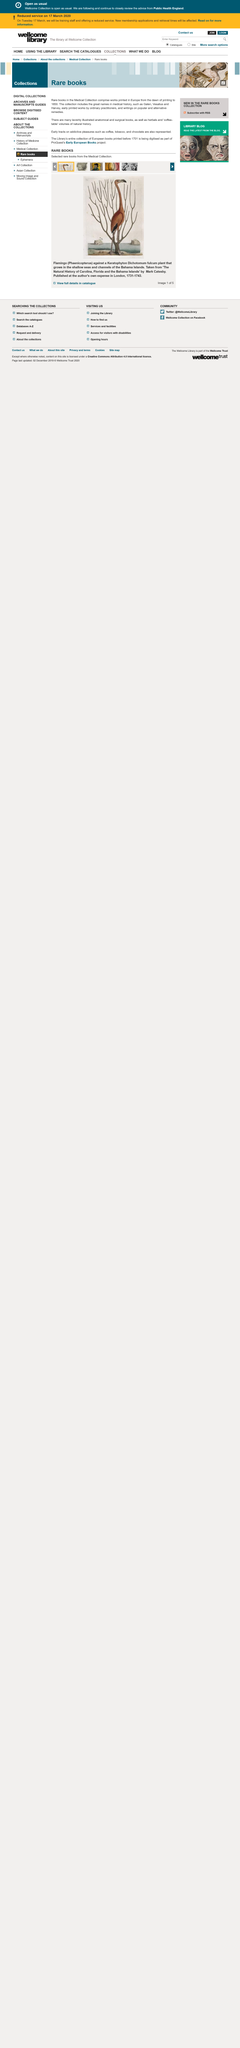List a handful of essential elements in this visual. The Medical Collection of rare books contains notable names such as Galen, Vesalius, and Harvey. The Medical Collection comprises rare books printed in Europe from the inception of printing up to 1850. The Library's entire collection of European books printed before 1701 has been digitised and is now available. 